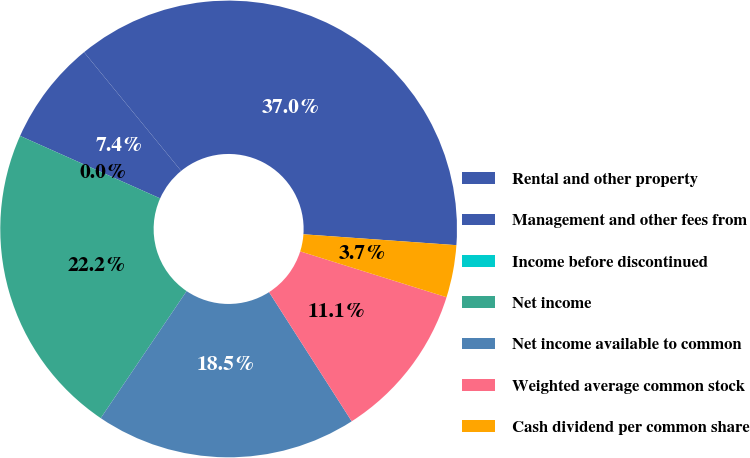Convert chart to OTSL. <chart><loc_0><loc_0><loc_500><loc_500><pie_chart><fcel>Rental and other property<fcel>Management and other fees from<fcel>Income before discontinued<fcel>Net income<fcel>Net income available to common<fcel>Weighted average common stock<fcel>Cash dividend per common share<nl><fcel>37.04%<fcel>7.41%<fcel>0.0%<fcel>22.22%<fcel>18.52%<fcel>11.11%<fcel>3.7%<nl></chart> 